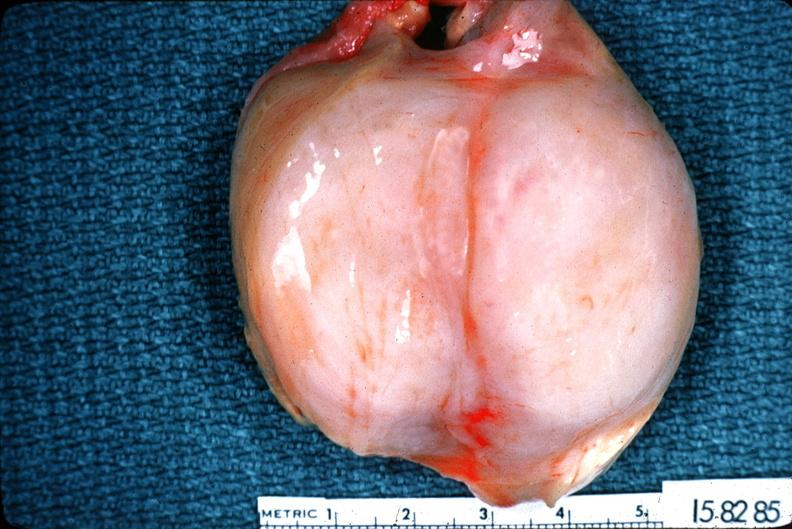what is present?
Answer the question using a single word or phrase. Nervous 